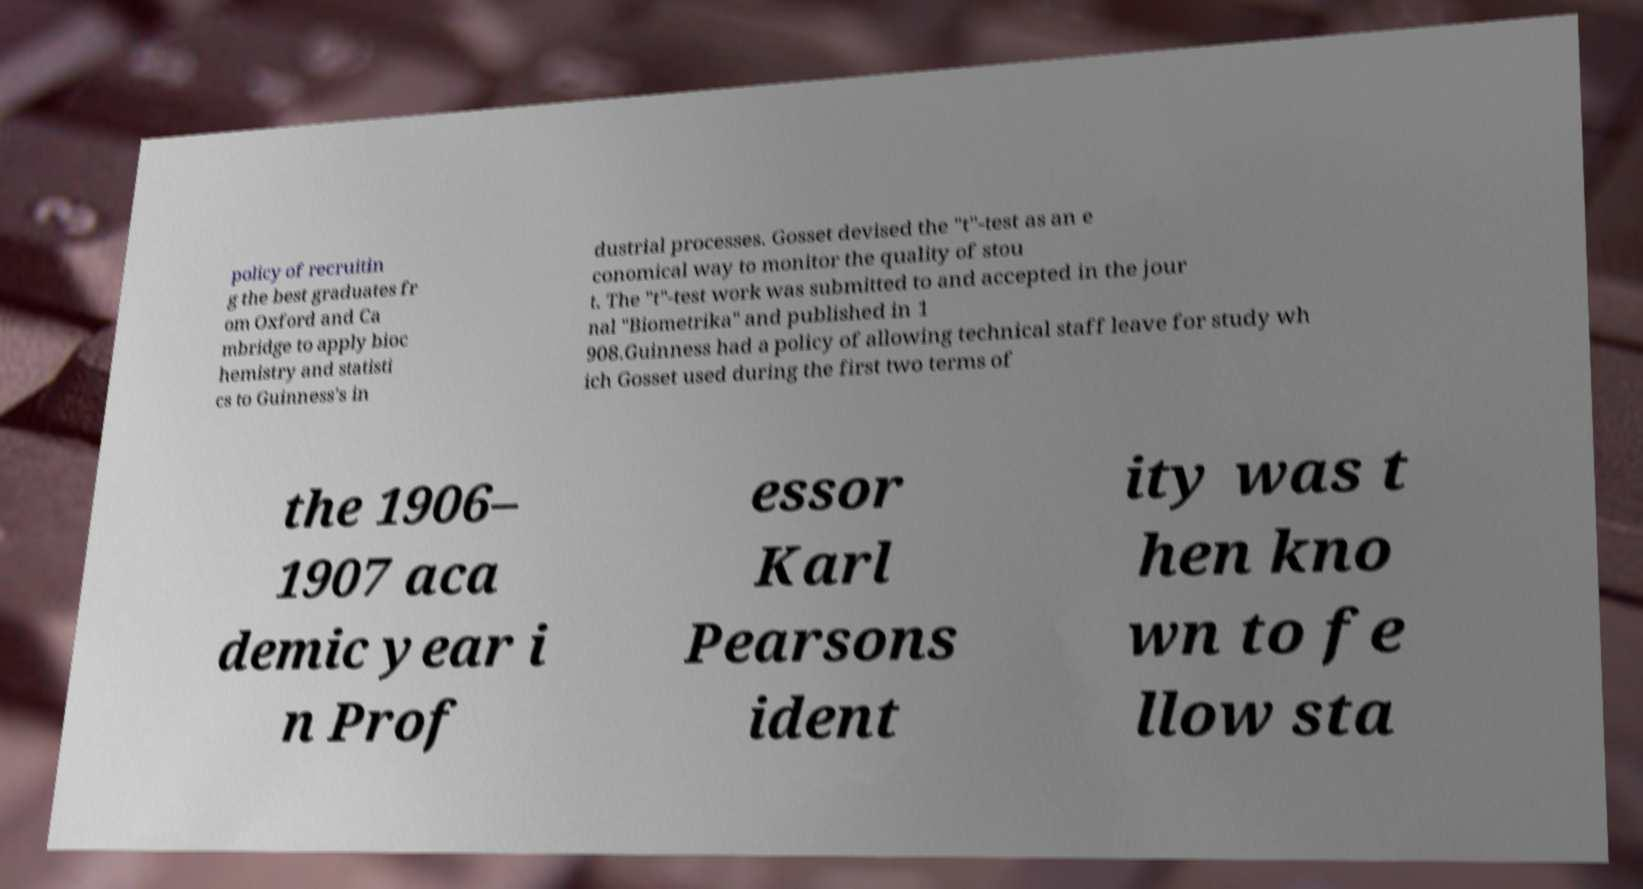Can you read and provide the text displayed in the image?This photo seems to have some interesting text. Can you extract and type it out for me? policy of recruitin g the best graduates fr om Oxford and Ca mbridge to apply bioc hemistry and statisti cs to Guinness's in dustrial processes. Gosset devised the "t"-test as an e conomical way to monitor the quality of stou t. The "t"-test work was submitted to and accepted in the jour nal "Biometrika" and published in 1 908.Guinness had a policy of allowing technical staff leave for study wh ich Gosset used during the first two terms of the 1906– 1907 aca demic year i n Prof essor Karl Pearsons ident ity was t hen kno wn to fe llow sta 